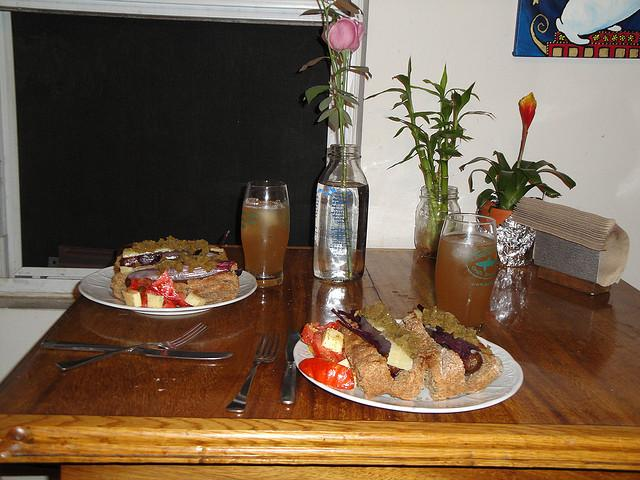What are the items in the brown and grey receptacle for?

Choices:
A) washing
B) stirring
C) wiping
D) eating wiping 